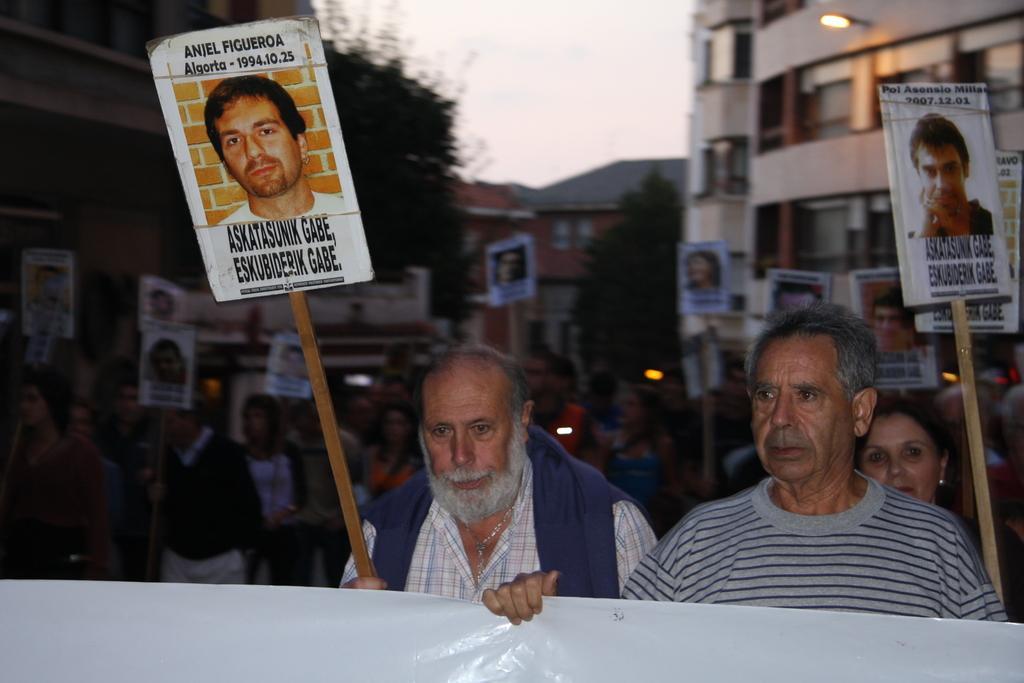In one or two sentences, can you explain what this image depicts? In this image in the middle there is a man, he wears a check shirt, he is holding a stick. On the right there is a man, he wears a t shirt, he is holding a poster. In the background there are many people, posters, boards, trees, buildings, lights and sky. 